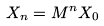Convert formula to latex. <formula><loc_0><loc_0><loc_500><loc_500>X _ { n } = M ^ { n } X _ { 0 }</formula> 